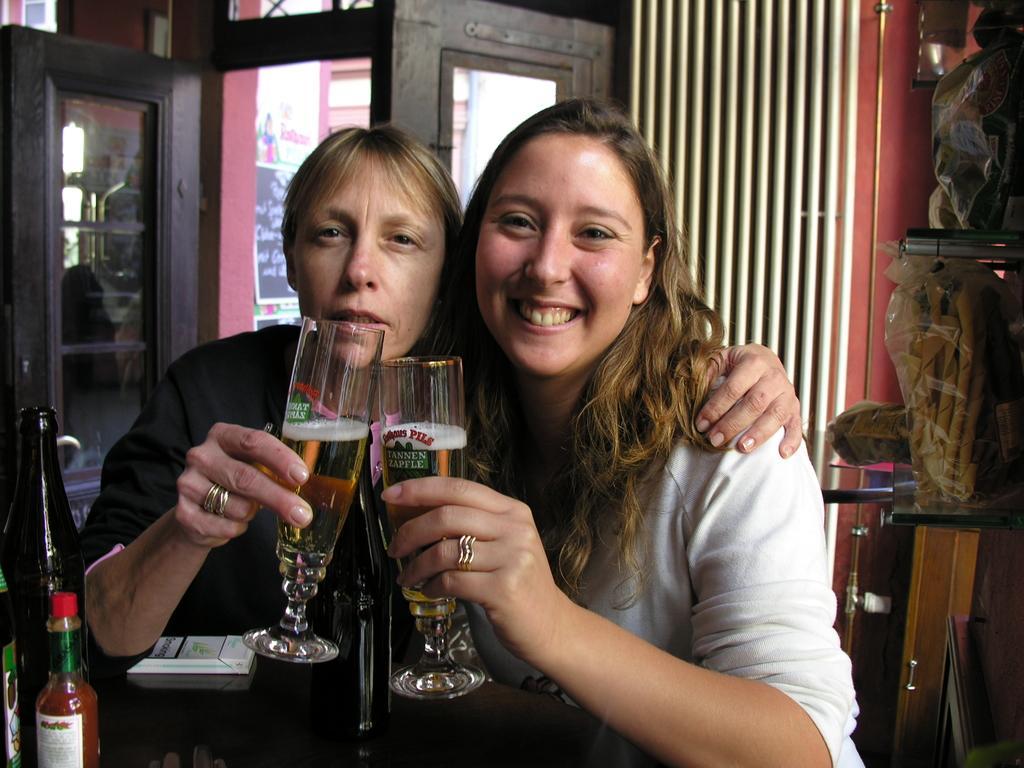Describe this image in one or two sentences. In this image, there are two people holding glasses. We can also see some objects like bottles on the surface. We can see some glass doors and the wall with some pipes. We can also see some objects in covers. We can also see some wood on the bottom right. 